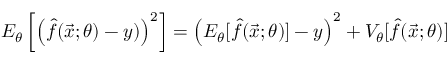<formula> <loc_0><loc_0><loc_500><loc_500>E _ { \theta } \left [ \left ( \hat { f } ( \vec { x } ; \theta ) - y ) \right ) ^ { 2 } \right ] = \left ( E _ { \theta } [ \hat { f } ( \vec { x } ; \theta ) ] - y \right ) ^ { 2 } + V _ { \theta } [ \hat { f } ( \vec { x } ; \theta ) ]</formula> 